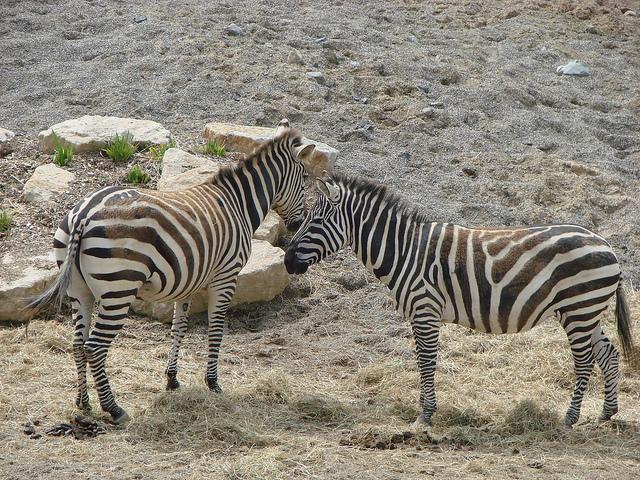How many zebras are there?
Give a very brief answer. 2. How many animals are there?
Give a very brief answer. 2. How many zebras are in the picture?
Give a very brief answer. 2. 